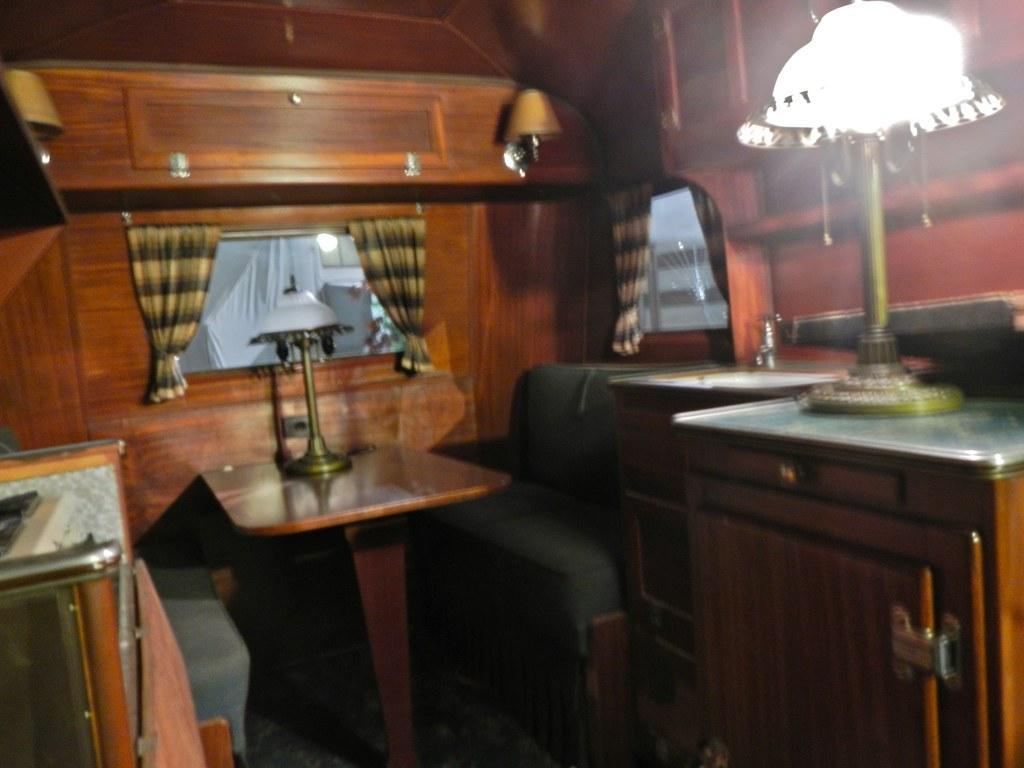Can you describe this image briefly? This image is taken indoors. In the background there is a wooden wall with windows. There are a few curtains. In the middle of the image there are a few tables with lamps on them. There are two benches. 